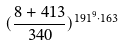Convert formula to latex. <formula><loc_0><loc_0><loc_500><loc_500>( \frac { 8 + 4 1 3 } { 3 4 0 } ) ^ { 1 9 1 ^ { 9 } \cdot 1 6 3 }</formula> 